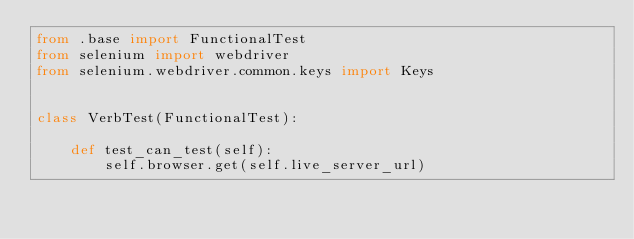<code> <loc_0><loc_0><loc_500><loc_500><_Python_>from .base import FunctionalTest
from selenium import webdriver
from selenium.webdriver.common.keys import Keys


class VerbTest(FunctionalTest):

    def test_can_test(self):
        self.browser.get(self.live_server_url)
</code> 